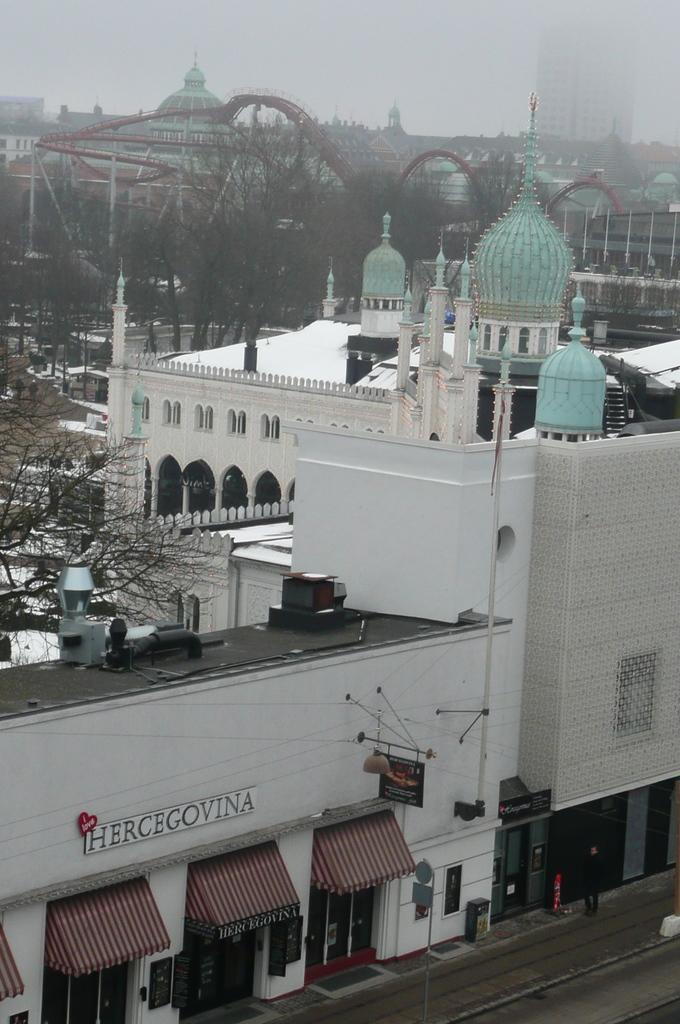Describe this image in one or two sentences. This picture is clicked outside the city. Here, we see many buildings and a mosque and we even see the bridge and there are many trees in the background. At the top of the picture, we see the sky and at the bottom of the picture, we see the man in black t-shirt is standing on sideways. 